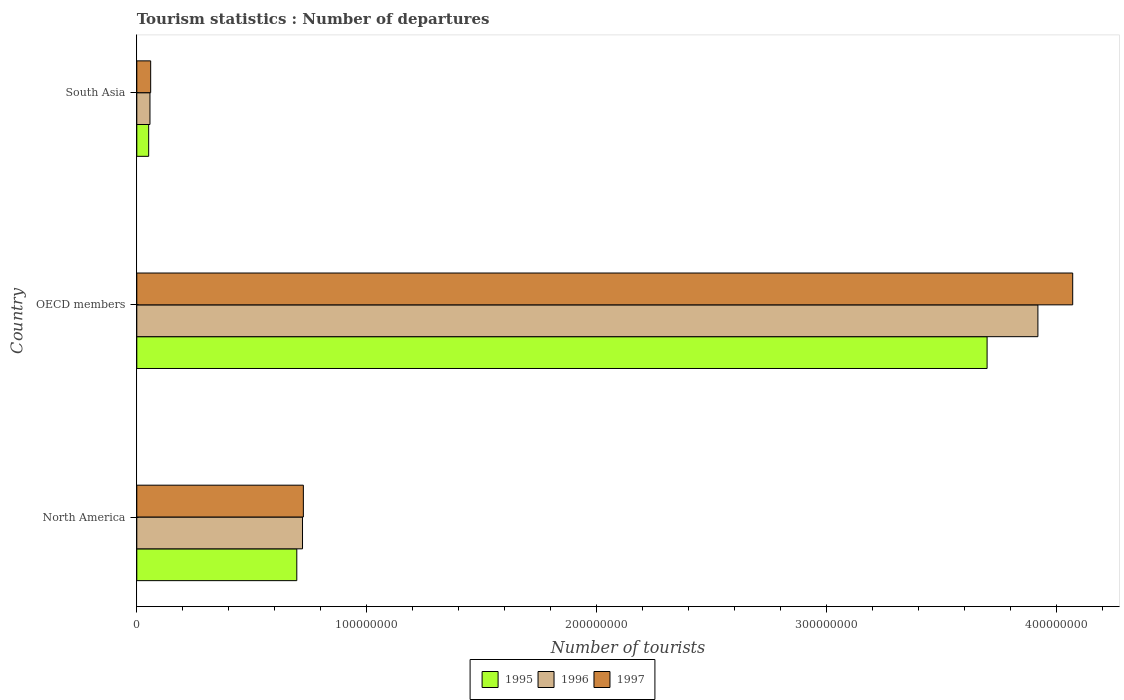How many different coloured bars are there?
Your answer should be compact. 3. How many groups of bars are there?
Keep it short and to the point. 3. Are the number of bars per tick equal to the number of legend labels?
Your response must be concise. Yes. How many bars are there on the 3rd tick from the top?
Your response must be concise. 3. How many bars are there on the 2nd tick from the bottom?
Ensure brevity in your answer.  3. In how many cases, is the number of bars for a given country not equal to the number of legend labels?
Give a very brief answer. 0. What is the number of tourist departures in 1995 in South Asia?
Ensure brevity in your answer.  5.17e+06. Across all countries, what is the maximum number of tourist departures in 1997?
Keep it short and to the point. 4.07e+08. Across all countries, what is the minimum number of tourist departures in 1997?
Provide a succinct answer. 6.04e+06. What is the total number of tourist departures in 1996 in the graph?
Ensure brevity in your answer.  4.70e+08. What is the difference between the number of tourist departures in 1997 in North America and that in OECD members?
Your answer should be very brief. -3.35e+08. What is the difference between the number of tourist departures in 1997 in North America and the number of tourist departures in 1995 in OECD members?
Keep it short and to the point. -2.97e+08. What is the average number of tourist departures in 1997 per country?
Your response must be concise. 1.62e+08. What is the difference between the number of tourist departures in 1996 and number of tourist departures in 1997 in North America?
Provide a succinct answer. -3.69e+05. In how many countries, is the number of tourist departures in 1997 greater than 120000000 ?
Provide a short and direct response. 1. What is the ratio of the number of tourist departures in 1995 in North America to that in OECD members?
Your answer should be very brief. 0.19. What is the difference between the highest and the second highest number of tourist departures in 1995?
Keep it short and to the point. 3.00e+08. What is the difference between the highest and the lowest number of tourist departures in 1995?
Your answer should be very brief. 3.65e+08. What does the 1st bar from the top in North America represents?
Offer a very short reply. 1997. What does the 2nd bar from the bottom in South Asia represents?
Give a very brief answer. 1996. Is it the case that in every country, the sum of the number of tourist departures in 1995 and number of tourist departures in 1996 is greater than the number of tourist departures in 1997?
Offer a very short reply. Yes. How many bars are there?
Your response must be concise. 9. Are all the bars in the graph horizontal?
Your answer should be compact. Yes. What is the difference between two consecutive major ticks on the X-axis?
Provide a succinct answer. 1.00e+08. How many legend labels are there?
Your answer should be compact. 3. How are the legend labels stacked?
Your answer should be very brief. Horizontal. What is the title of the graph?
Offer a terse response. Tourism statistics : Number of departures. Does "2004" appear as one of the legend labels in the graph?
Your answer should be compact. No. What is the label or title of the X-axis?
Provide a short and direct response. Number of tourists. What is the label or title of the Y-axis?
Keep it short and to the point. Country. What is the Number of tourists in 1995 in North America?
Provide a short and direct response. 6.96e+07. What is the Number of tourists of 1996 in North America?
Your response must be concise. 7.21e+07. What is the Number of tourists in 1997 in North America?
Ensure brevity in your answer.  7.25e+07. What is the Number of tourists of 1995 in OECD members?
Ensure brevity in your answer.  3.70e+08. What is the Number of tourists of 1996 in OECD members?
Provide a succinct answer. 3.92e+08. What is the Number of tourists in 1997 in OECD members?
Provide a succinct answer. 4.07e+08. What is the Number of tourists of 1995 in South Asia?
Provide a short and direct response. 5.17e+06. What is the Number of tourists of 1996 in South Asia?
Your response must be concise. 5.74e+06. What is the Number of tourists in 1997 in South Asia?
Offer a very short reply. 6.04e+06. Across all countries, what is the maximum Number of tourists in 1995?
Your response must be concise. 3.70e+08. Across all countries, what is the maximum Number of tourists in 1996?
Your answer should be compact. 3.92e+08. Across all countries, what is the maximum Number of tourists in 1997?
Give a very brief answer. 4.07e+08. Across all countries, what is the minimum Number of tourists of 1995?
Your response must be concise. 5.17e+06. Across all countries, what is the minimum Number of tourists of 1996?
Keep it short and to the point. 5.74e+06. Across all countries, what is the minimum Number of tourists in 1997?
Ensure brevity in your answer.  6.04e+06. What is the total Number of tourists in 1995 in the graph?
Offer a terse response. 4.45e+08. What is the total Number of tourists of 1996 in the graph?
Make the answer very short. 4.70e+08. What is the total Number of tourists in 1997 in the graph?
Make the answer very short. 4.86e+08. What is the difference between the Number of tourists of 1995 in North America and that in OECD members?
Keep it short and to the point. -3.00e+08. What is the difference between the Number of tourists in 1996 in North America and that in OECD members?
Make the answer very short. -3.20e+08. What is the difference between the Number of tourists of 1997 in North America and that in OECD members?
Your response must be concise. -3.35e+08. What is the difference between the Number of tourists of 1995 in North America and that in South Asia?
Give a very brief answer. 6.44e+07. What is the difference between the Number of tourists in 1996 in North America and that in South Asia?
Give a very brief answer. 6.64e+07. What is the difference between the Number of tourists in 1997 in North America and that in South Asia?
Provide a succinct answer. 6.64e+07. What is the difference between the Number of tourists of 1995 in OECD members and that in South Asia?
Your response must be concise. 3.65e+08. What is the difference between the Number of tourists of 1996 in OECD members and that in South Asia?
Your response must be concise. 3.86e+08. What is the difference between the Number of tourists in 1997 in OECD members and that in South Asia?
Your response must be concise. 4.01e+08. What is the difference between the Number of tourists of 1995 in North America and the Number of tourists of 1996 in OECD members?
Your response must be concise. -3.22e+08. What is the difference between the Number of tourists of 1995 in North America and the Number of tourists of 1997 in OECD members?
Offer a very short reply. -3.38e+08. What is the difference between the Number of tourists in 1996 in North America and the Number of tourists in 1997 in OECD members?
Ensure brevity in your answer.  -3.35e+08. What is the difference between the Number of tourists of 1995 in North America and the Number of tourists of 1996 in South Asia?
Offer a very short reply. 6.39e+07. What is the difference between the Number of tourists of 1995 in North America and the Number of tourists of 1997 in South Asia?
Give a very brief answer. 6.36e+07. What is the difference between the Number of tourists in 1996 in North America and the Number of tourists in 1997 in South Asia?
Your answer should be compact. 6.61e+07. What is the difference between the Number of tourists in 1995 in OECD members and the Number of tourists in 1996 in South Asia?
Ensure brevity in your answer.  3.64e+08. What is the difference between the Number of tourists of 1995 in OECD members and the Number of tourists of 1997 in South Asia?
Your answer should be compact. 3.64e+08. What is the difference between the Number of tourists in 1996 in OECD members and the Number of tourists in 1997 in South Asia?
Offer a very short reply. 3.86e+08. What is the average Number of tourists in 1995 per country?
Your answer should be compact. 1.48e+08. What is the average Number of tourists of 1996 per country?
Offer a terse response. 1.57e+08. What is the average Number of tourists of 1997 per country?
Ensure brevity in your answer.  1.62e+08. What is the difference between the Number of tourists of 1995 and Number of tourists of 1996 in North America?
Provide a short and direct response. -2.49e+06. What is the difference between the Number of tourists of 1995 and Number of tourists of 1997 in North America?
Your answer should be very brief. -2.85e+06. What is the difference between the Number of tourists in 1996 and Number of tourists in 1997 in North America?
Your answer should be compact. -3.69e+05. What is the difference between the Number of tourists of 1995 and Number of tourists of 1996 in OECD members?
Your answer should be compact. -2.21e+07. What is the difference between the Number of tourists of 1995 and Number of tourists of 1997 in OECD members?
Provide a short and direct response. -3.72e+07. What is the difference between the Number of tourists in 1996 and Number of tourists in 1997 in OECD members?
Provide a succinct answer. -1.51e+07. What is the difference between the Number of tourists of 1995 and Number of tourists of 1996 in South Asia?
Your answer should be compact. -5.69e+05. What is the difference between the Number of tourists of 1995 and Number of tourists of 1997 in South Asia?
Make the answer very short. -8.75e+05. What is the difference between the Number of tourists in 1996 and Number of tourists in 1997 in South Asia?
Offer a very short reply. -3.06e+05. What is the ratio of the Number of tourists in 1995 in North America to that in OECD members?
Offer a terse response. 0.19. What is the ratio of the Number of tourists of 1996 in North America to that in OECD members?
Keep it short and to the point. 0.18. What is the ratio of the Number of tourists of 1997 in North America to that in OECD members?
Provide a succinct answer. 0.18. What is the ratio of the Number of tourists in 1995 in North America to that in South Asia?
Offer a terse response. 13.47. What is the ratio of the Number of tourists of 1996 in North America to that in South Asia?
Offer a terse response. 12.57. What is the ratio of the Number of tourists in 1997 in North America to that in South Asia?
Ensure brevity in your answer.  12. What is the ratio of the Number of tourists in 1995 in OECD members to that in South Asia?
Give a very brief answer. 71.61. What is the ratio of the Number of tourists in 1996 in OECD members to that in South Asia?
Your answer should be very brief. 68.36. What is the ratio of the Number of tourists in 1997 in OECD members to that in South Asia?
Offer a very short reply. 67.4. What is the difference between the highest and the second highest Number of tourists of 1995?
Make the answer very short. 3.00e+08. What is the difference between the highest and the second highest Number of tourists in 1996?
Offer a terse response. 3.20e+08. What is the difference between the highest and the second highest Number of tourists of 1997?
Your response must be concise. 3.35e+08. What is the difference between the highest and the lowest Number of tourists in 1995?
Your answer should be compact. 3.65e+08. What is the difference between the highest and the lowest Number of tourists in 1996?
Provide a short and direct response. 3.86e+08. What is the difference between the highest and the lowest Number of tourists in 1997?
Your answer should be compact. 4.01e+08. 